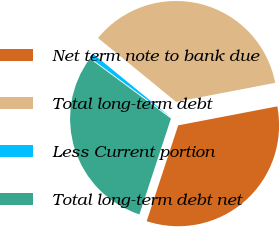Convert chart to OTSL. <chart><loc_0><loc_0><loc_500><loc_500><pie_chart><fcel>Net term note to bank due<fcel>Total long-term debt<fcel>Less Current portion<fcel>Total long-term debt net<nl><fcel>33.07%<fcel>36.08%<fcel>0.78%<fcel>30.07%<nl></chart> 